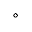Convert formula to latex. <formula><loc_0><loc_0><loc_500><loc_500>\circ</formula> 